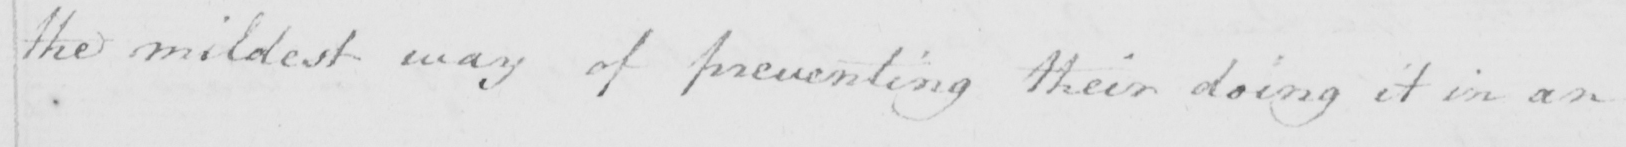Can you tell me what this handwritten text says? the mildest way of preventing their doing it in an 